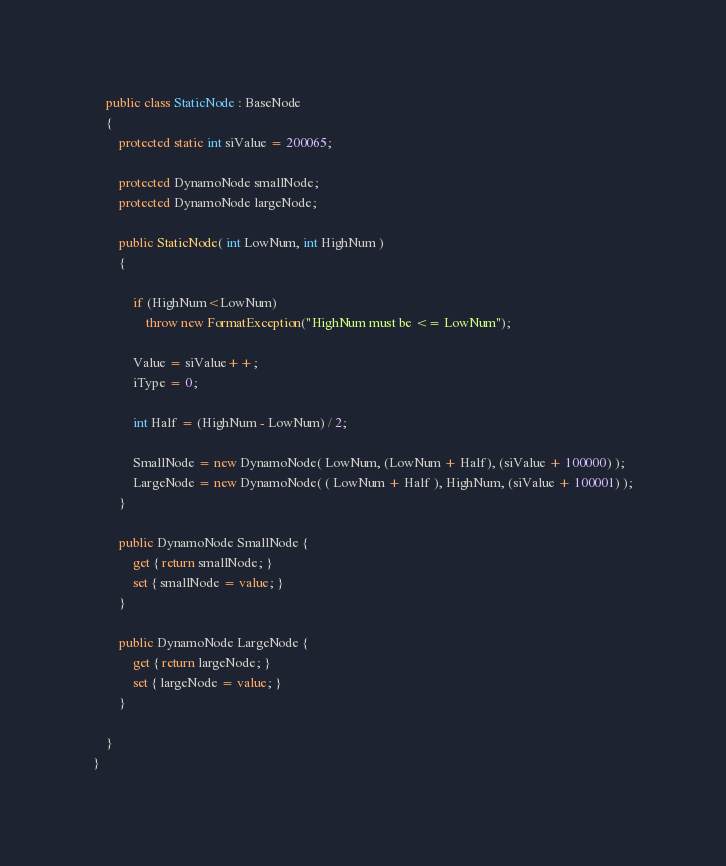<code> <loc_0><loc_0><loc_500><loc_500><_C#_>
    public class StaticNode : BaseNode
    {
        protected static int siValue = 200065;

        protected DynamoNode smallNode;
        protected DynamoNode largeNode;

        public StaticNode( int LowNum, int HighNum )
        {

            if (HighNum<LowNum)
                throw new FormatException("HighNum must be <= LowNum");

            Value = siValue++;
            iType = 0;

            int Half = (HighNum - LowNum) / 2;

            SmallNode = new DynamoNode( LowNum, (LowNum + Half), (siValue + 100000) );
            LargeNode = new DynamoNode( ( LowNum + Half ), HighNum, (siValue + 100001) );
        }

        public DynamoNode SmallNode {
            get { return smallNode; }
            set { smallNode = value; }
        }

        public DynamoNode LargeNode {
            get { return largeNode; }
            set { largeNode = value; }
        }

    }
}
</code> 